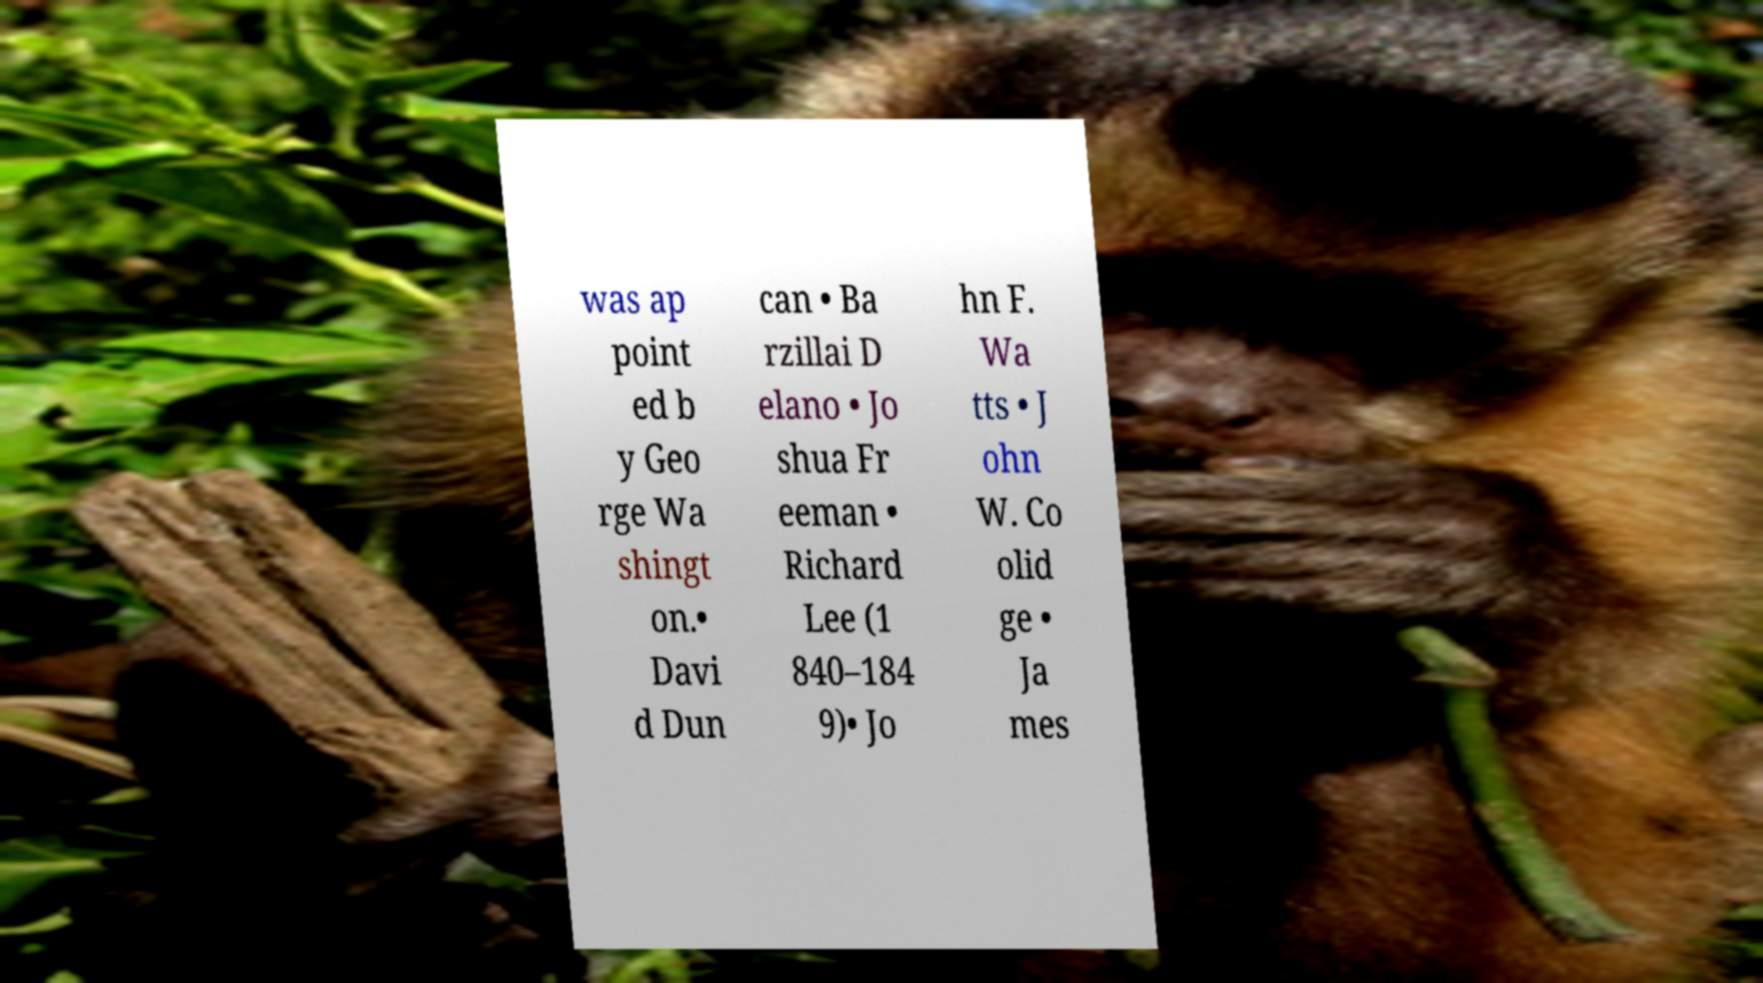Can you accurately transcribe the text from the provided image for me? was ap point ed b y Geo rge Wa shingt on.• Davi d Dun can • Ba rzillai D elano • Jo shua Fr eeman • Richard Lee (1 840–184 9)• Jo hn F. Wa tts • J ohn W. Co olid ge • Ja mes 